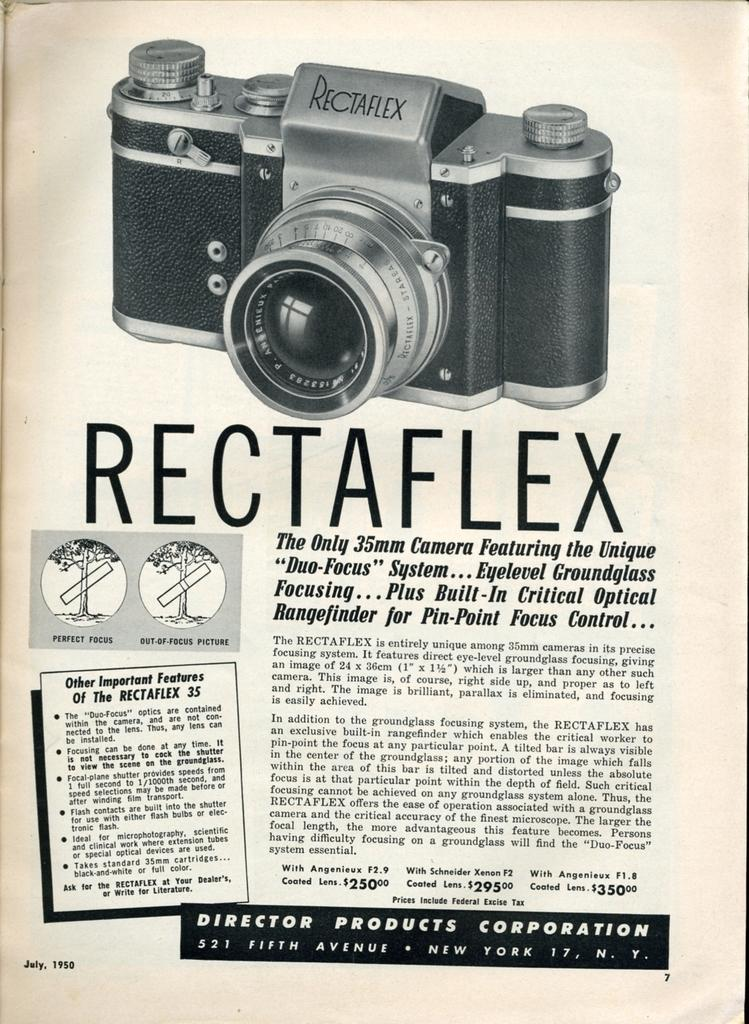What is present on the paper in the image? There is a paper in the image, and there is text on the paper. What object is also visible in the image? There is a camera in the image. Can you tell me how many worms are crawling on the paper in the image? There are no worms present on the paper in the image. What type of grandmother is visible in the image? There is no grandmother present in the image. 